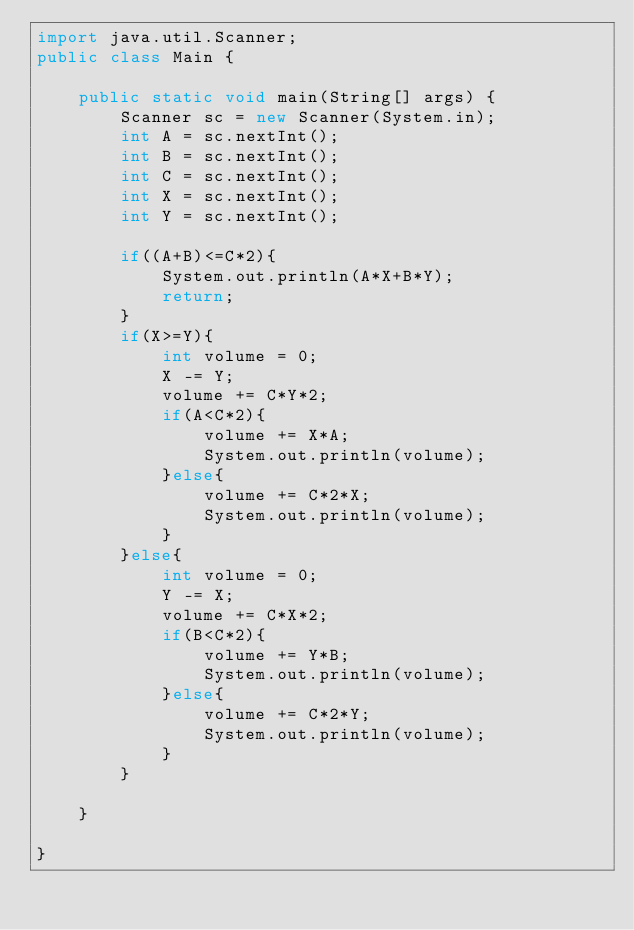<code> <loc_0><loc_0><loc_500><loc_500><_Java_>import java.util.Scanner;
public class Main {

	public static void main(String[] args) {
		Scanner sc = new Scanner(System.in);
		int A = sc.nextInt();
		int B = sc.nextInt();
		int C = sc.nextInt();
		int X = sc.nextInt();
		int Y = sc.nextInt();

		if((A+B)<=C*2){
			System.out.println(A*X+B*Y);
			return;
		}
		if(X>=Y){
			int volume = 0;
			X -= Y;
			volume += C*Y*2;
			if(A<C*2){
				volume += X*A;
				System.out.println(volume);
			}else{
				volume += C*2*X;
				System.out.println(volume);
			}
		}else{
			int volume = 0;
			Y -= X;
			volume += C*X*2;
			if(B<C*2){
				volume += Y*B;
				System.out.println(volume);
			}else{
				volume += C*2*Y;
				System.out.println(volume);
			}
		}

	}

}
</code> 